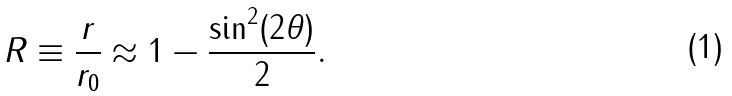Convert formula to latex. <formula><loc_0><loc_0><loc_500><loc_500>R \equiv \frac { r } { r _ { 0 } } \approx 1 - \frac { \sin ^ { 2 } ( 2 \theta ) } { 2 } .</formula> 